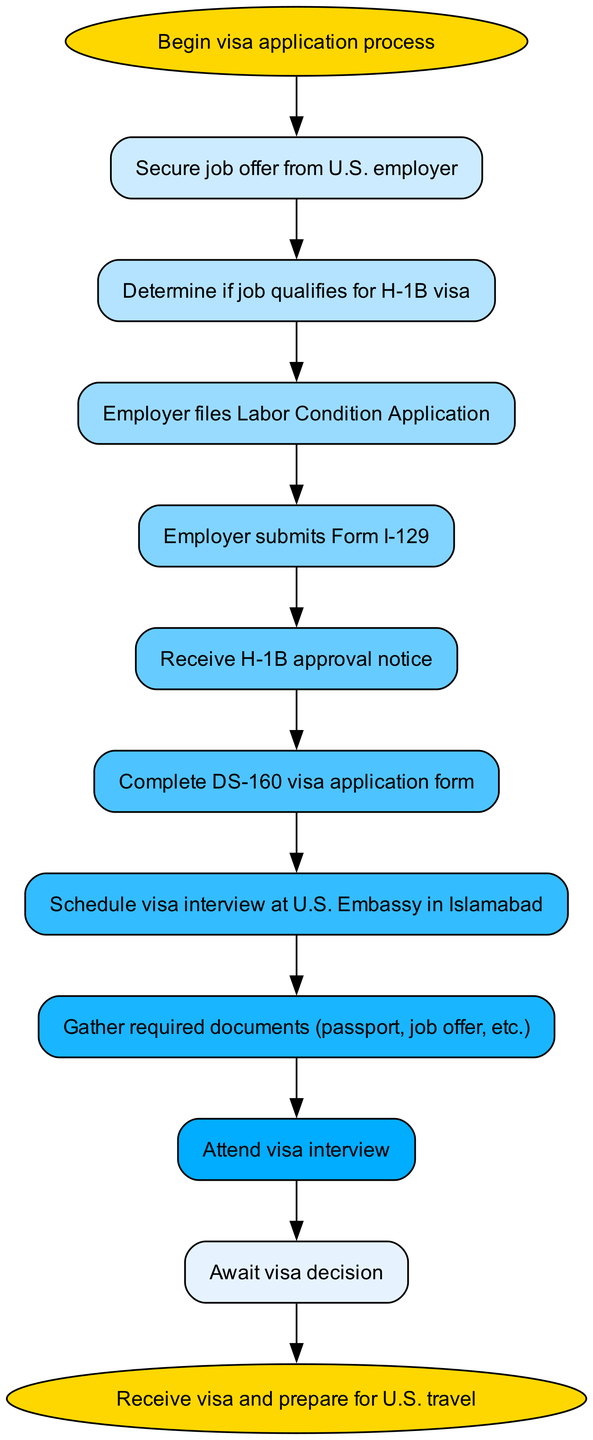What is the first step in the U.S. work visa application process? The first step in the diagram is labeled 'Begin visa application process', which is represented as the first node in the flow.
Answer: Begin visa application process How many nodes are there in the flow chart? The diagram contains a total of 12 nodes, which include both the start and end points, as well as all the intermediary steps in the visa application process.
Answer: 12 What document does the employer need to submit after filing the Labor Condition Application? According to the diagram, the next step after the Labor Condition Application is for the employer to submit Form I-129, which is an essential part of the visa application process.
Answer: Form I-129 What is the last action in the process before receiving the visa? The last action before receiving the visa is to 'Await visa decision', which is identified as the penultimate step in the flow chart leading up to obtaining the visa.
Answer: Await visa decision What is required to complete after receiving the H-1B approval notice? After receiving the H-1B approval notice, the following step is to 'Complete DS-160 visa application form', indicating that this form must be filled out before proceeding to the interview stage.
Answer: Complete DS-160 visa application form If a Sulkhanpur native is at the document gathering stage, which node precedes this? In the flow chart, the gathering of required documents comes after attending the visa interview, meaning the last action before this step is to 'Attend visa interview'.
Answer: Attend visa interview Which step involves the U.S. Embassy in Islamabad? The step that includes the U.S. Embassy in Islamabad is 'Schedule visa interview at U.S. Embassy in Islamabad', making it clear that this is where the visa interview takes place.
Answer: Schedule visa interview at U.S. Embassy in Islamabad What is the purpose of the Labor Condition Application? The purpose of the Labor Condition Application is related to the employment regulations and is necessary for the employer to legally apply for an H-1B visa, which is clearly shown as a requirement in the visa application process.
Answer: Labor Condition Application What type of visa is focused on in this flow chart? The flow chart specifically focuses on the H-1B visa, indicated clearly at the point in the process where qualifications are determined, emphasizing the specific visa type aimed at professional workers.
Answer: H-1B visa 